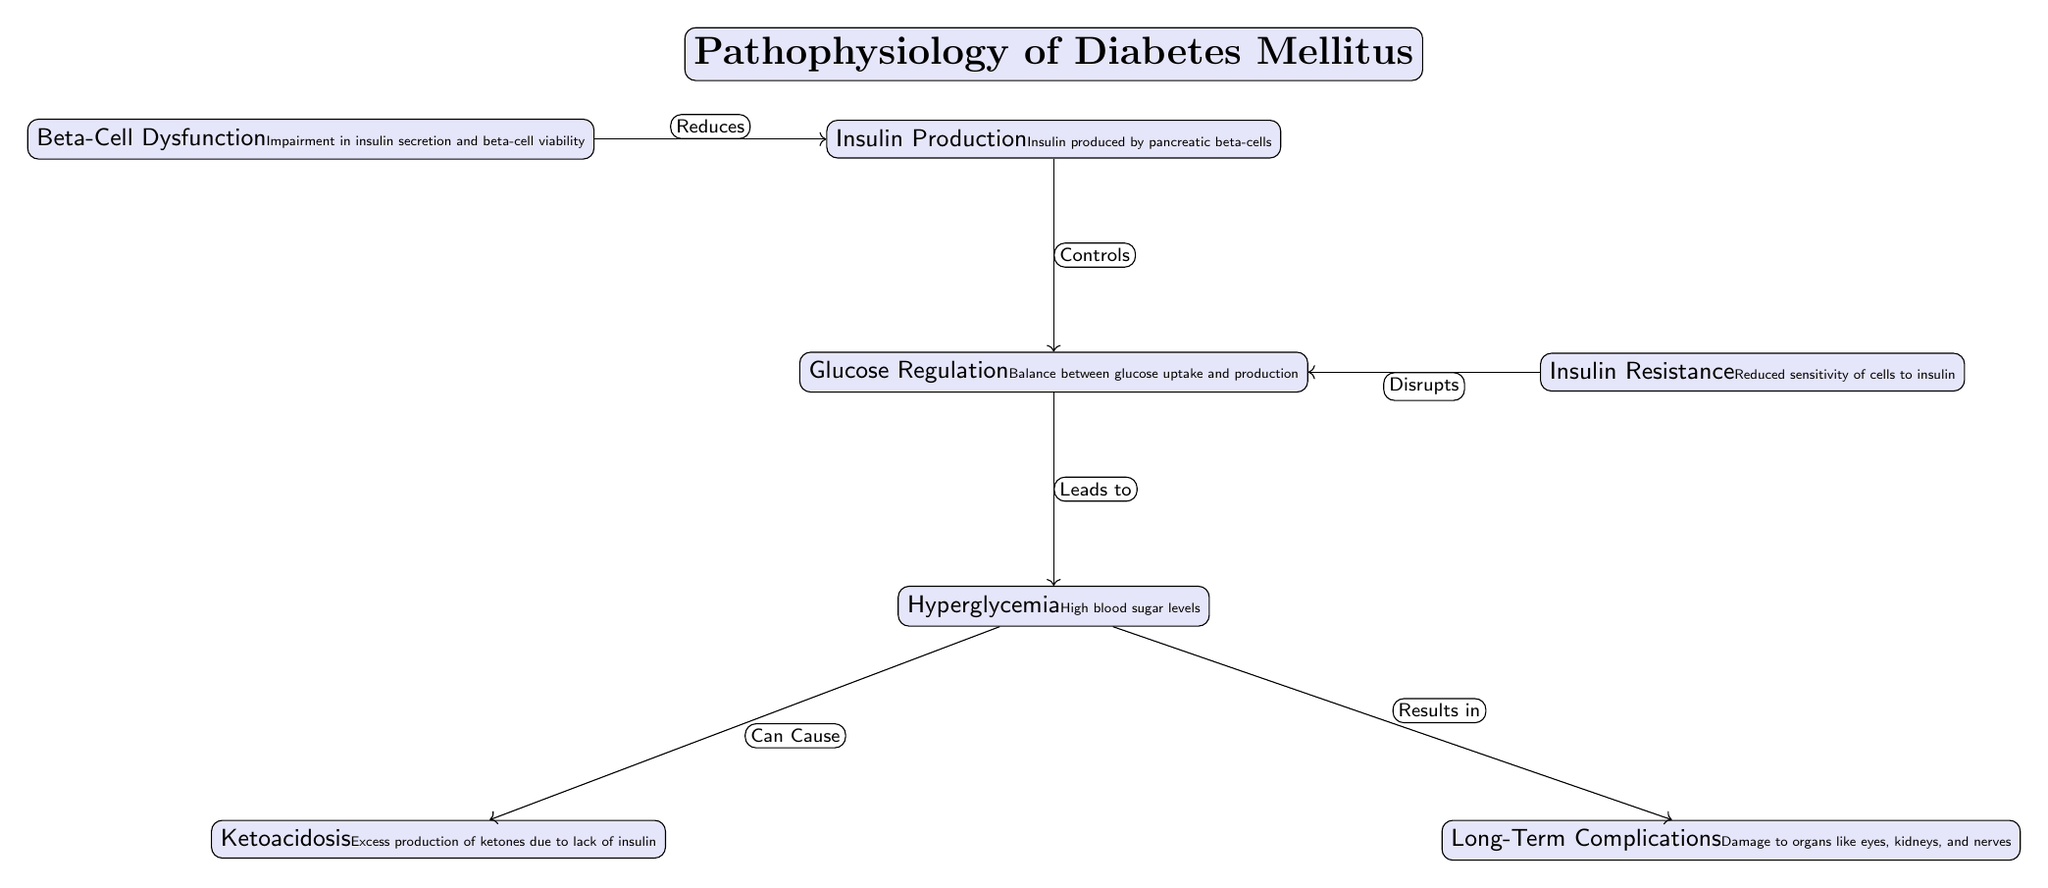What is produced by pancreatic beta-cells? The diagram labels the node "Insulin Production" which specifies that insulin is produced by pancreatic beta-cells.
Answer: Insulin What does beta-cell dysfunction reduce? From the diagram, there is an arrow labeled "Reduces" pointing from "Beta-Cell Dysfunction" to "Insulin Production," indicating that beta-cell dysfunction reduces insulin production.
Answer: Insulin Production Which condition leads to hyperglycemia? The diagram shows that "Glucose Regulation" leads to "Hyperglycemia," suggesting that improper glucose regulation is the cause of hyperglycemia.
Answer: Glucose Regulation How many long-term complications are listed in the diagram? The diagram includes one node titled "Long-Term Complications," showing that there is one main category for these complications.
Answer: One What is the consequence of hyperglycemia according to the diagram? The diagram indicates that "Hyperglycemia" leads to "Ketoacidosis" and also results in "Long-Term Complications." This indicates the consequences that stem from hyperglycemia.
Answer: Ketoacidosis, Long-Term Complications What effect does insulin resistance have on glucose regulation? The relationship shown in the diagram indicates that "Insulin Resistance" disrupts "Glucose Regulation," meaning that insulin resistance negatively impacts how glucose is regulated.
Answer: Disrupts Which factor controls glucose regulation? The arrow labeled "Controls" points from "Insulin Production" to "Glucose Regulation," indicating that insulin production is the controlling factor for glucose regulation.
Answer: Insulin Production What does hyperglycemia indicate about blood sugar levels? The node "Hyperglycemia" specifies that it refers to high blood sugar levels, directly indicating what hyperglycemia represents.
Answer: High blood sugar levels 